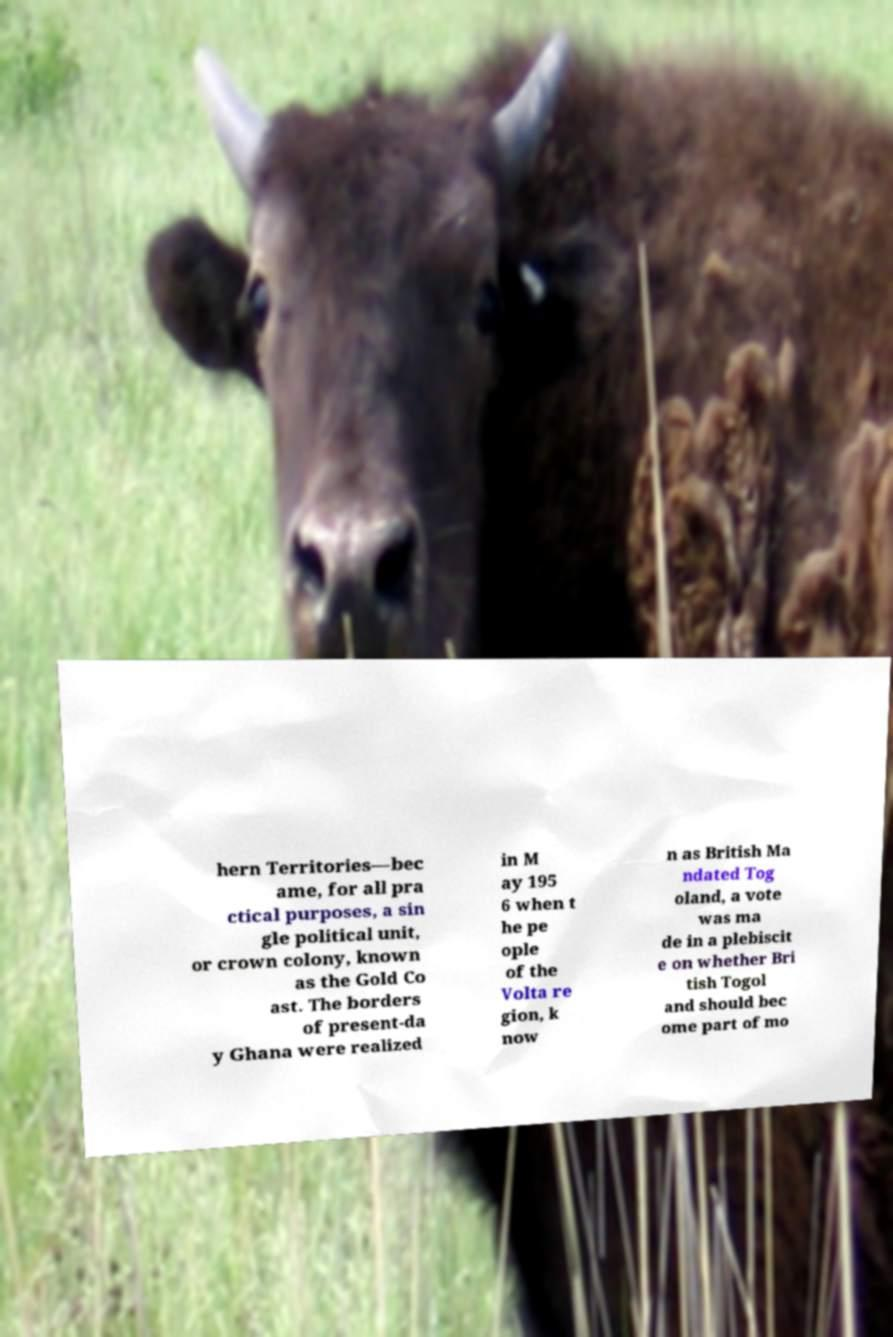Could you assist in decoding the text presented in this image and type it out clearly? hern Territories—bec ame, for all pra ctical purposes, a sin gle political unit, or crown colony, known as the Gold Co ast. The borders of present-da y Ghana were realized in M ay 195 6 when t he pe ople of the Volta re gion, k now n as British Ma ndated Tog oland, a vote was ma de in a plebiscit e on whether Bri tish Togol and should bec ome part of mo 